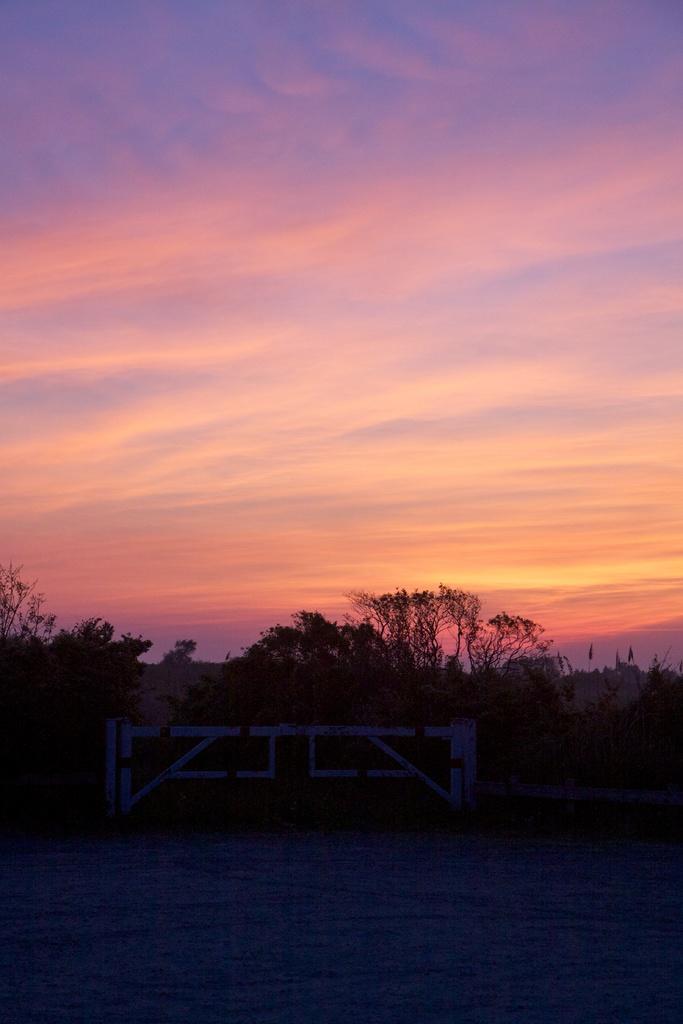Describe this image in one or two sentences. This image is clicked on the road. Beside the road there is a wall. In the center there is a gate to the wall. Behind the wall there are trees. At the top there is the sky. 